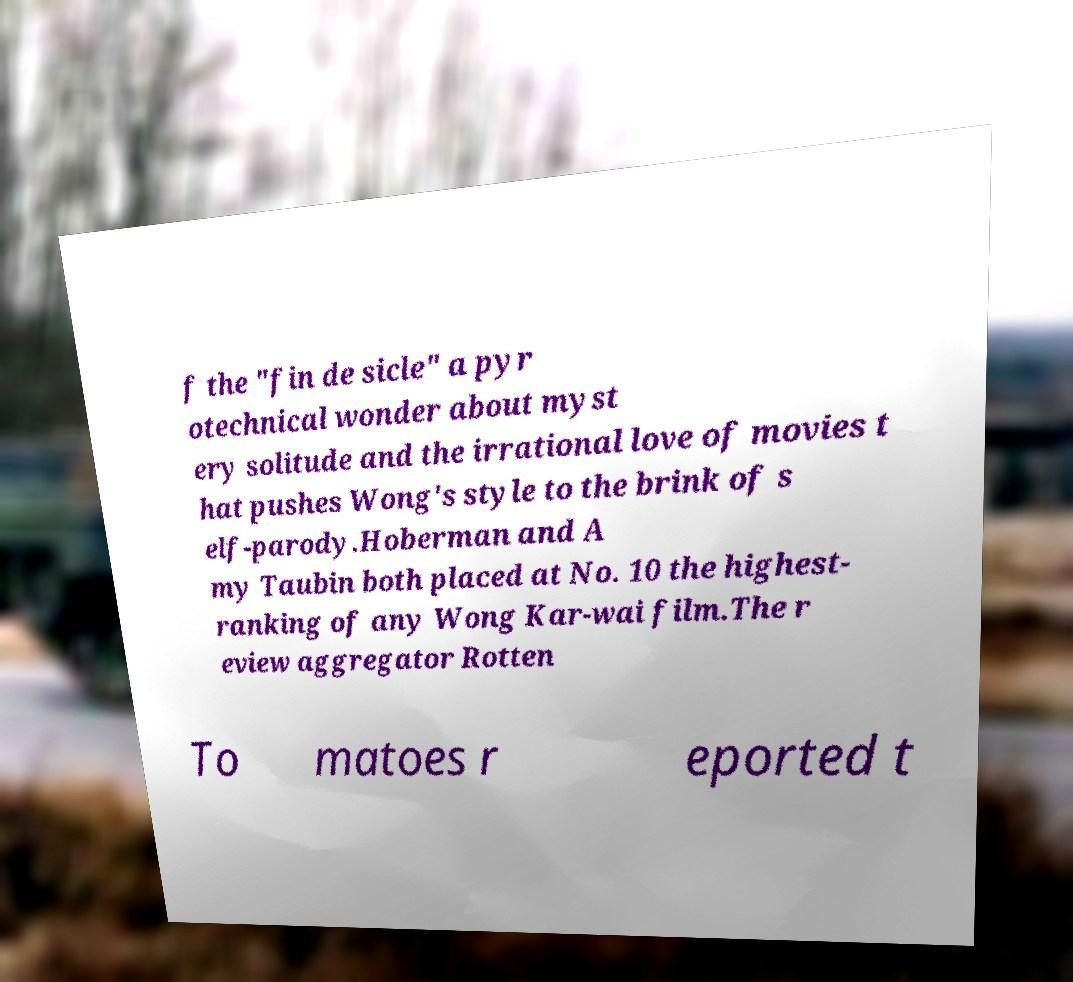Please read and relay the text visible in this image. What does it say? f the "fin de sicle" a pyr otechnical wonder about myst ery solitude and the irrational love of movies t hat pushes Wong's style to the brink of s elf-parody.Hoberman and A my Taubin both placed at No. 10 the highest- ranking of any Wong Kar-wai film.The r eview aggregator Rotten To matoes r eported t 